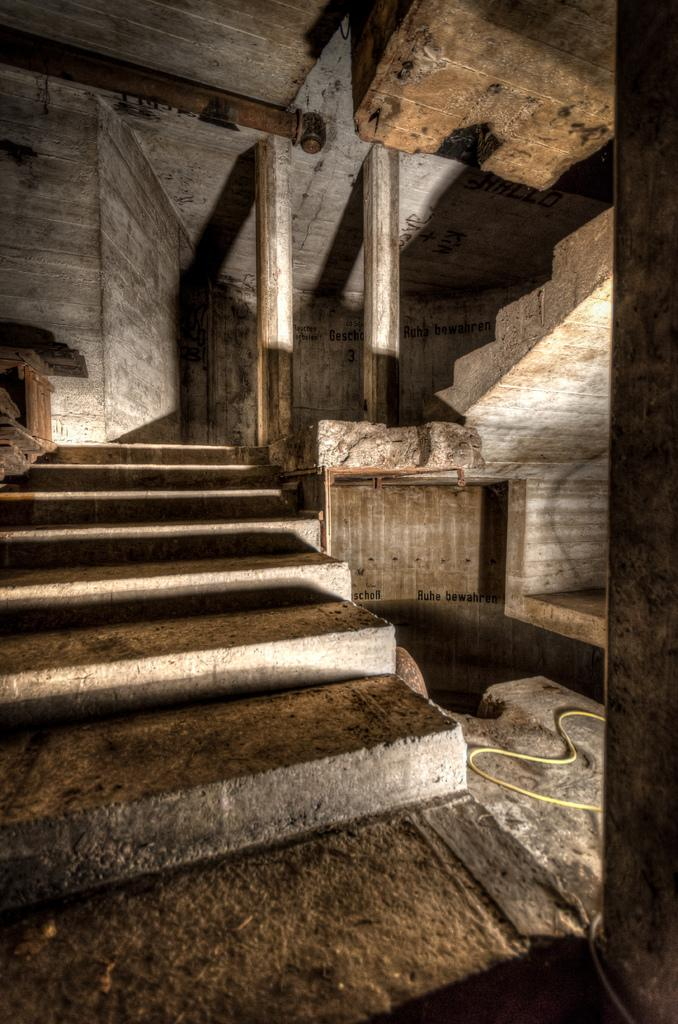What architectural feature is visible in the image? There are steps in the image. What other structural elements can be seen in the image? There are pillars and a wall in the image. What object is lying on the floor in the image? There is a pipe on the floor in the image. What type of skirt is hanging on the wall in the image? There is no skirt present in the image; only steps, pillars, a wall, and a pipe are visible. 